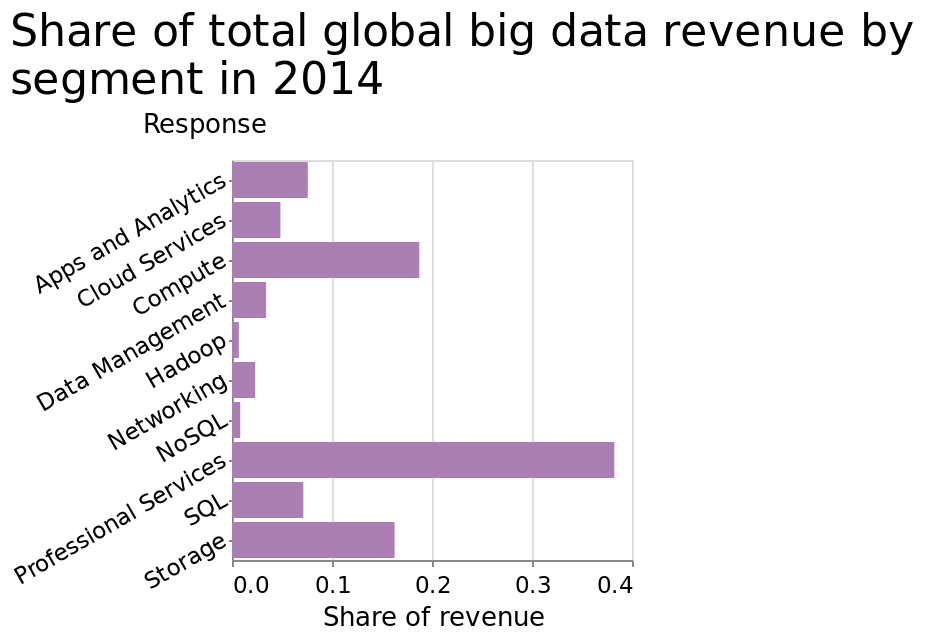<image>
What are the two ends of the categorical scale on the y-axis? The two ends of the categorical scale on the y-axis are "Apps and Analytics" on one end and "Storage" on the other. Which category has the highest share of revenue?  Professional Services has the highest share of revenue. What does the x-axis represent on the bar chart? The x-axis on the bar chart represents the share of revenue using a linear scale from 0.0 to 0.4. 